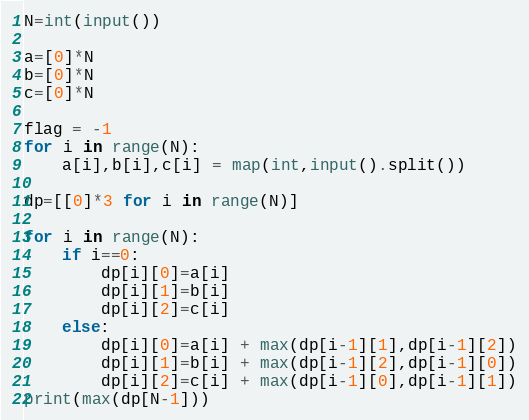<code> <loc_0><loc_0><loc_500><loc_500><_Python_>N=int(input())

a=[0]*N
b=[0]*N
c=[0]*N

flag = -1
for i in range(N):
    a[i],b[i],c[i] = map(int,input().split())

dp=[[0]*3 for i in range(N)]

for i in range(N):
    if i==0:
        dp[i][0]=a[i]
        dp[i][1]=b[i]
        dp[i][2]=c[i]
    else:
        dp[i][0]=a[i] + max(dp[i-1][1],dp[i-1][2])
        dp[i][1]=b[i] + max(dp[i-1][2],dp[i-1][0])
        dp[i][2]=c[i] + max(dp[i-1][0],dp[i-1][1])
print(max(dp[N-1]))</code> 